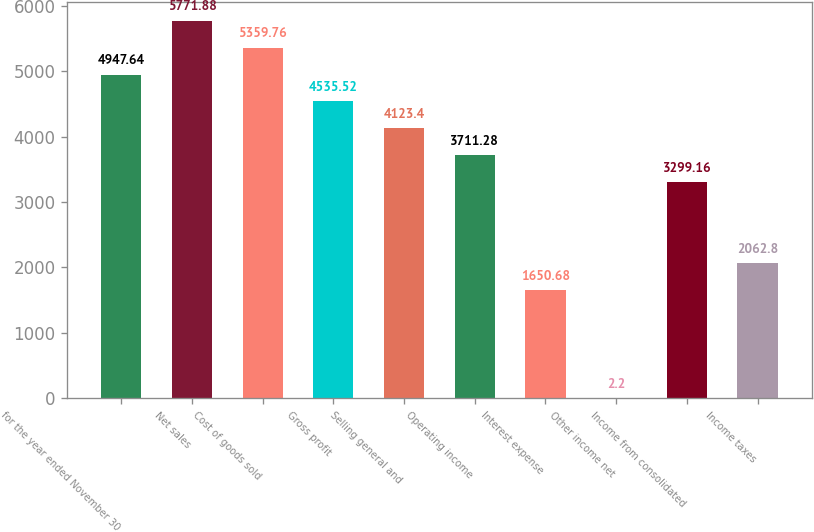Convert chart. <chart><loc_0><loc_0><loc_500><loc_500><bar_chart><fcel>for the year ended November 30<fcel>Net sales<fcel>Cost of goods sold<fcel>Gross profit<fcel>Selling general and<fcel>Operating income<fcel>Interest expense<fcel>Other income net<fcel>Income from consolidated<fcel>Income taxes<nl><fcel>4947.64<fcel>5771.88<fcel>5359.76<fcel>4535.52<fcel>4123.4<fcel>3711.28<fcel>1650.68<fcel>2.2<fcel>3299.16<fcel>2062.8<nl></chart> 